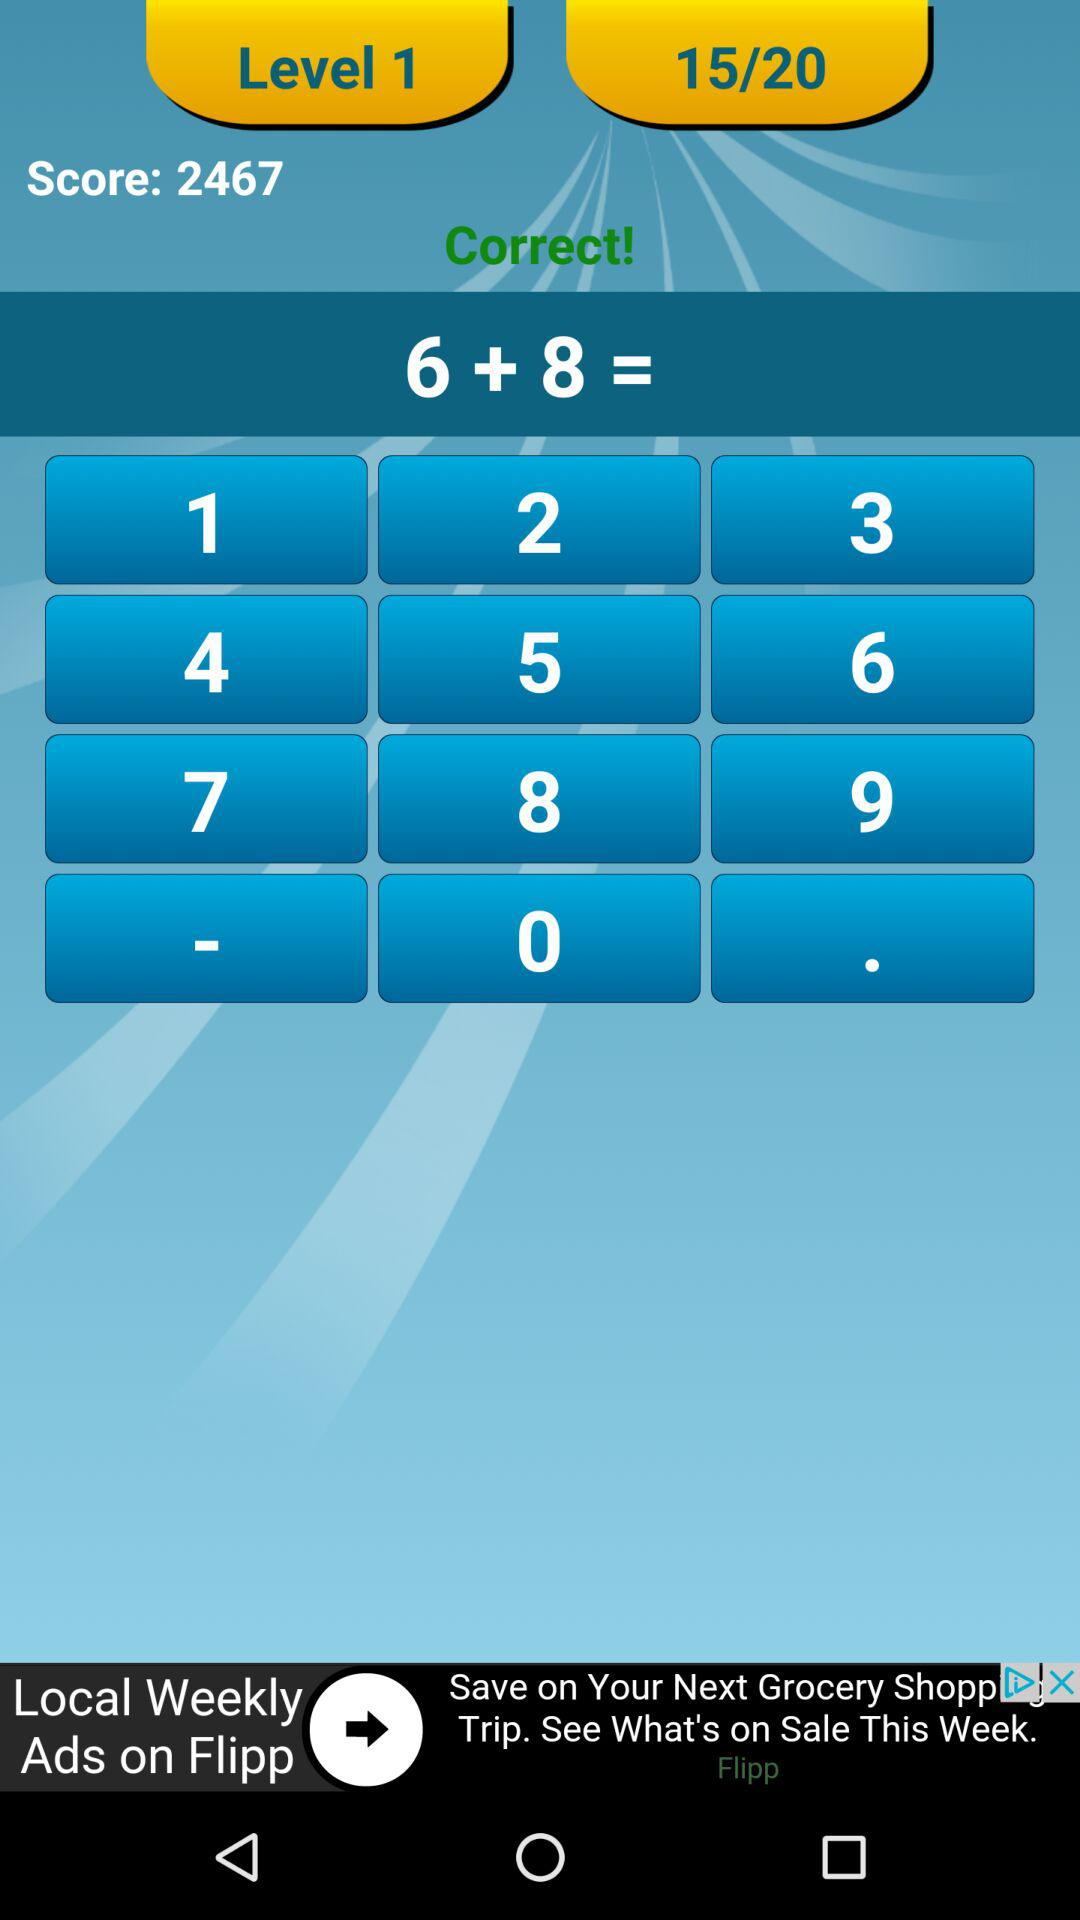On what question number are we at? You are on question number 15. 